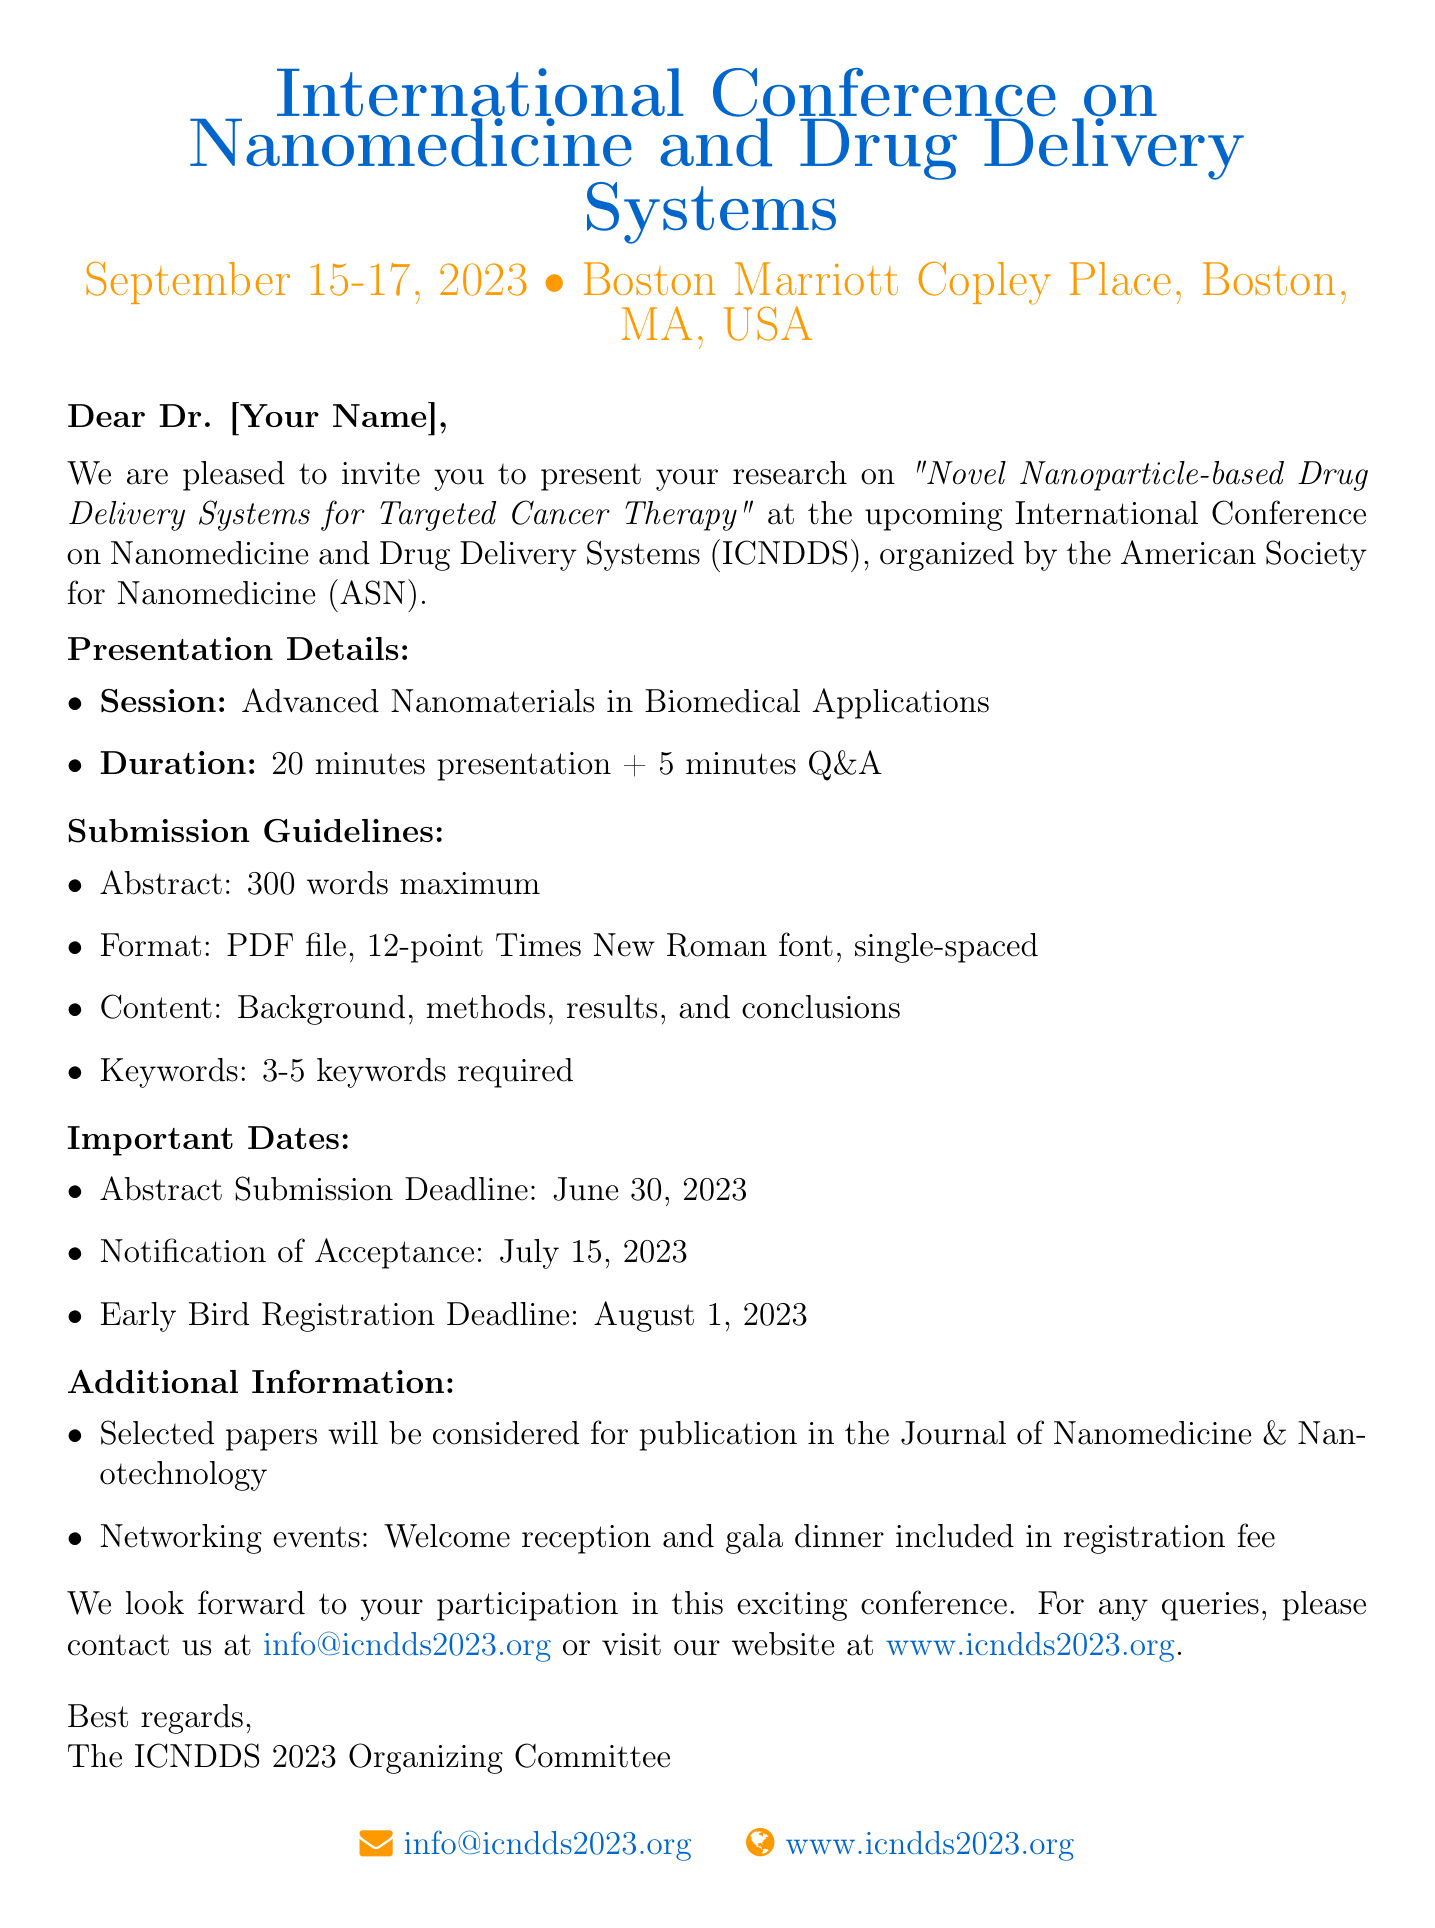What is the conference name? The name of the conference is mentioned at the beginning of the document.
Answer: International Conference on Nanomedicine and Drug Delivery Systems What are the conference dates? The conference dates are specified in the introductory section of the document.
Answer: September 15-17, 2023 Where is the conference located? The location of the conference is provided in the first section of the document.
Answer: Boston Marriott Copley Place, Boston, MA, USA What is the abstract submission deadline? The important dates section lists the abstract submission deadline clearly.
Answer: June 30, 2023 What is the presentation duration? The duration of the presentation is outlined in the presentation details section.
Answer: 20 minutes + 5 minutes Q&A How many keywords are required? The submission guidelines specify the number of keywords needed for the abstract.
Answer: 3-5 keywords required Who organizes the conference? The organizing body is mentioned in the invitation details section.
Answer: American Society for Nanomedicine (ASN) What is the opportunity after presentation? Additional information describes a specific opportunity for selected presenters.
Answer: Publication in the Journal of Nanomedicine & Nanotechnology What kind of events are included in the registration fee? The additional information section mentions the types of networking events included with registration.
Answer: Welcome reception and gala dinner 